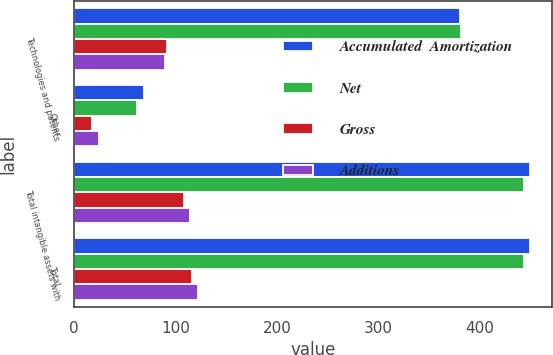Convert chart. <chart><loc_0><loc_0><loc_500><loc_500><stacked_bar_chart><ecel><fcel>Technologies and patents<fcel>Other<fcel>Total intangible assets with<fcel>Total<nl><fcel>Accumulated  Amortization<fcel>380<fcel>68.9<fcel>448.9<fcel>448.9<nl><fcel>Net<fcel>381.4<fcel>62.2<fcel>443.6<fcel>443.6<nl><fcel>Gross<fcel>91.1<fcel>17.5<fcel>108.6<fcel>116.5<nl><fcel>Additions<fcel>89.7<fcel>24.2<fcel>113.9<fcel>121.8<nl></chart> 